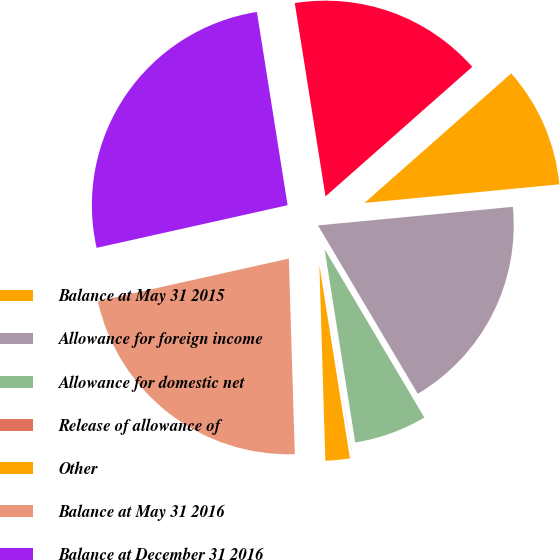<chart> <loc_0><loc_0><loc_500><loc_500><pie_chart><fcel>Balance at May 31 2015<fcel>Allowance for foreign income<fcel>Allowance for domestic net<fcel>Release of allowance of<fcel>Other<fcel>Balance at May 31 2016<fcel>Balance at December 31 2016<fcel>Allowance for foreign net<nl><fcel>10.0%<fcel>18.0%<fcel>6.01%<fcel>0.01%<fcel>2.01%<fcel>21.99%<fcel>25.99%<fcel>16.0%<nl></chart> 